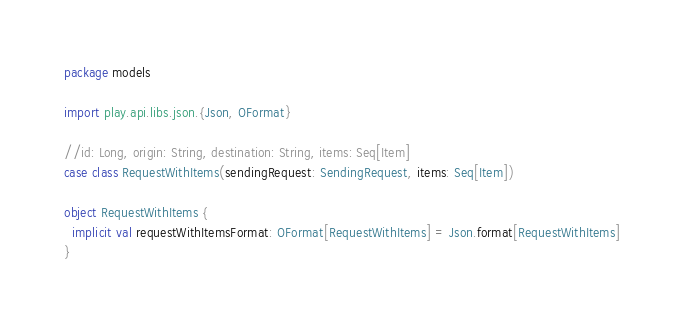Convert code to text. <code><loc_0><loc_0><loc_500><loc_500><_Scala_>package models

import play.api.libs.json.{Json, OFormat}

//id: Long, origin: String, destination: String, items: Seq[Item]
case class RequestWithItems(sendingRequest: SendingRequest, items: Seq[Item])

object RequestWithItems {
  implicit val requestWithItemsFormat: OFormat[RequestWithItems] = Json.format[RequestWithItems]
}</code> 